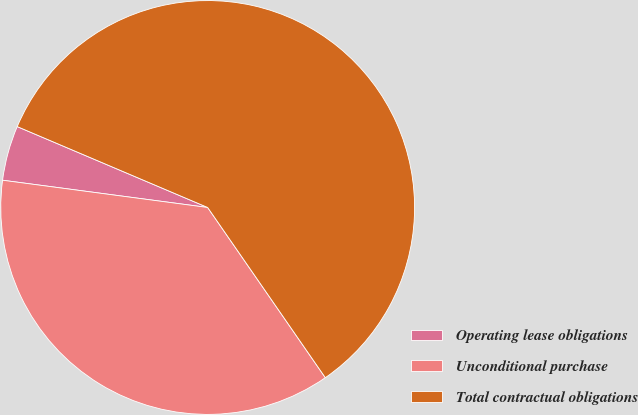<chart> <loc_0><loc_0><loc_500><loc_500><pie_chart><fcel>Operating lease obligations<fcel>Unconditional purchase<fcel>Total contractual obligations<nl><fcel>4.29%<fcel>36.73%<fcel>58.98%<nl></chart> 